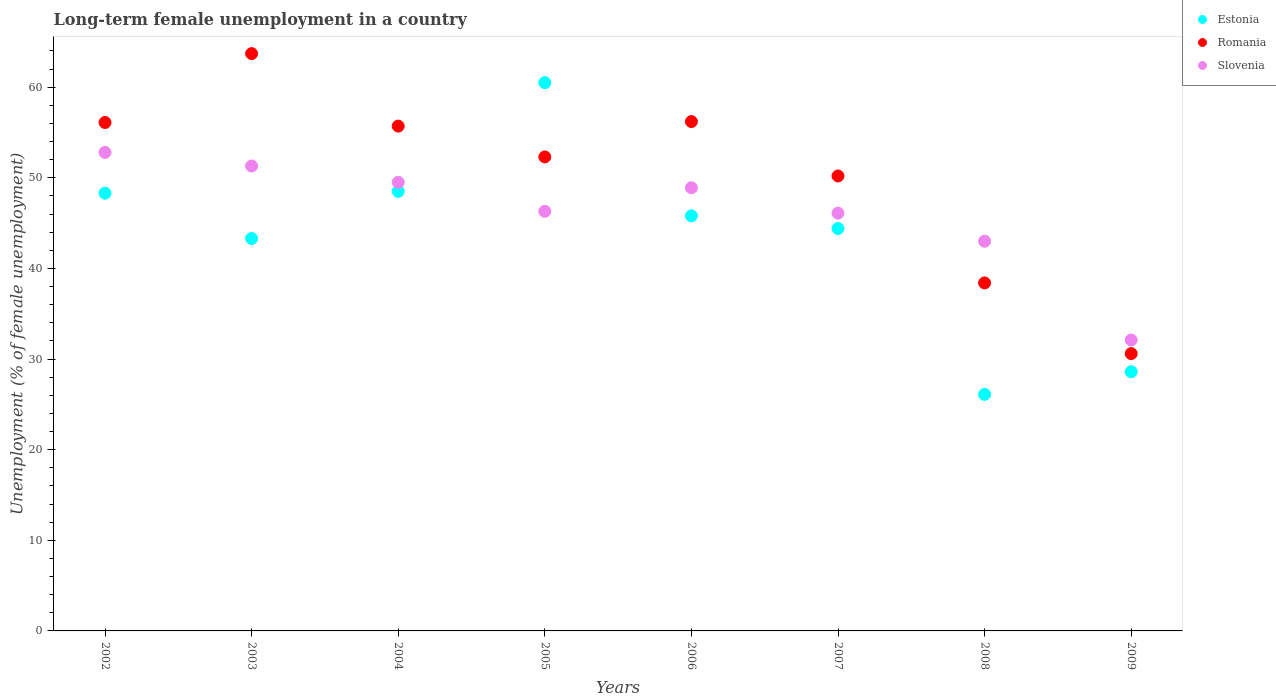How many different coloured dotlines are there?
Your answer should be compact. 3. Is the number of dotlines equal to the number of legend labels?
Offer a very short reply. Yes. What is the percentage of long-term unemployed female population in Estonia in 2002?
Offer a terse response. 48.3. Across all years, what is the maximum percentage of long-term unemployed female population in Slovenia?
Offer a very short reply. 52.8. Across all years, what is the minimum percentage of long-term unemployed female population in Romania?
Provide a succinct answer. 30.6. In which year was the percentage of long-term unemployed female population in Romania maximum?
Offer a very short reply. 2003. In which year was the percentage of long-term unemployed female population in Estonia minimum?
Make the answer very short. 2008. What is the total percentage of long-term unemployed female population in Estonia in the graph?
Offer a very short reply. 345.5. What is the difference between the percentage of long-term unemployed female population in Romania in 2002 and that in 2003?
Keep it short and to the point. -7.6. What is the difference between the percentage of long-term unemployed female population in Slovenia in 2005 and the percentage of long-term unemployed female population in Estonia in 2009?
Offer a very short reply. 17.7. What is the average percentage of long-term unemployed female population in Estonia per year?
Your answer should be compact. 43.19. In the year 2009, what is the difference between the percentage of long-term unemployed female population in Estonia and percentage of long-term unemployed female population in Romania?
Your response must be concise. -2. In how many years, is the percentage of long-term unemployed female population in Romania greater than 42 %?
Offer a very short reply. 6. What is the ratio of the percentage of long-term unemployed female population in Romania in 2005 to that in 2009?
Ensure brevity in your answer.  1.71. Is the difference between the percentage of long-term unemployed female population in Estonia in 2002 and 2008 greater than the difference between the percentage of long-term unemployed female population in Romania in 2002 and 2008?
Provide a short and direct response. Yes. What is the difference between the highest and the lowest percentage of long-term unemployed female population in Romania?
Your answer should be very brief. 33.1. Does the percentage of long-term unemployed female population in Slovenia monotonically increase over the years?
Your answer should be very brief. No. How many dotlines are there?
Your answer should be very brief. 3. What is the difference between two consecutive major ticks on the Y-axis?
Ensure brevity in your answer.  10. Does the graph contain any zero values?
Provide a short and direct response. No. How many legend labels are there?
Ensure brevity in your answer.  3. How are the legend labels stacked?
Your answer should be compact. Vertical. What is the title of the graph?
Give a very brief answer. Long-term female unemployment in a country. Does "Monaco" appear as one of the legend labels in the graph?
Provide a short and direct response. No. What is the label or title of the X-axis?
Give a very brief answer. Years. What is the label or title of the Y-axis?
Offer a terse response. Unemployment (% of female unemployment). What is the Unemployment (% of female unemployment) of Estonia in 2002?
Your answer should be very brief. 48.3. What is the Unemployment (% of female unemployment) of Romania in 2002?
Provide a short and direct response. 56.1. What is the Unemployment (% of female unemployment) of Slovenia in 2002?
Keep it short and to the point. 52.8. What is the Unemployment (% of female unemployment) of Estonia in 2003?
Your response must be concise. 43.3. What is the Unemployment (% of female unemployment) in Romania in 2003?
Ensure brevity in your answer.  63.7. What is the Unemployment (% of female unemployment) in Slovenia in 2003?
Offer a very short reply. 51.3. What is the Unemployment (% of female unemployment) of Estonia in 2004?
Keep it short and to the point. 48.5. What is the Unemployment (% of female unemployment) in Romania in 2004?
Your answer should be very brief. 55.7. What is the Unemployment (% of female unemployment) of Slovenia in 2004?
Keep it short and to the point. 49.5. What is the Unemployment (% of female unemployment) of Estonia in 2005?
Ensure brevity in your answer.  60.5. What is the Unemployment (% of female unemployment) of Romania in 2005?
Your answer should be compact. 52.3. What is the Unemployment (% of female unemployment) in Slovenia in 2005?
Offer a very short reply. 46.3. What is the Unemployment (% of female unemployment) of Estonia in 2006?
Offer a very short reply. 45.8. What is the Unemployment (% of female unemployment) of Romania in 2006?
Keep it short and to the point. 56.2. What is the Unemployment (% of female unemployment) in Slovenia in 2006?
Ensure brevity in your answer.  48.9. What is the Unemployment (% of female unemployment) of Estonia in 2007?
Make the answer very short. 44.4. What is the Unemployment (% of female unemployment) of Romania in 2007?
Give a very brief answer. 50.2. What is the Unemployment (% of female unemployment) in Slovenia in 2007?
Provide a succinct answer. 46.1. What is the Unemployment (% of female unemployment) in Estonia in 2008?
Give a very brief answer. 26.1. What is the Unemployment (% of female unemployment) of Romania in 2008?
Ensure brevity in your answer.  38.4. What is the Unemployment (% of female unemployment) of Slovenia in 2008?
Provide a succinct answer. 43. What is the Unemployment (% of female unemployment) in Estonia in 2009?
Your answer should be compact. 28.6. What is the Unemployment (% of female unemployment) in Romania in 2009?
Provide a succinct answer. 30.6. What is the Unemployment (% of female unemployment) of Slovenia in 2009?
Make the answer very short. 32.1. Across all years, what is the maximum Unemployment (% of female unemployment) in Estonia?
Your answer should be very brief. 60.5. Across all years, what is the maximum Unemployment (% of female unemployment) in Romania?
Offer a terse response. 63.7. Across all years, what is the maximum Unemployment (% of female unemployment) in Slovenia?
Ensure brevity in your answer.  52.8. Across all years, what is the minimum Unemployment (% of female unemployment) in Estonia?
Your response must be concise. 26.1. Across all years, what is the minimum Unemployment (% of female unemployment) of Romania?
Offer a very short reply. 30.6. Across all years, what is the minimum Unemployment (% of female unemployment) in Slovenia?
Provide a succinct answer. 32.1. What is the total Unemployment (% of female unemployment) of Estonia in the graph?
Provide a short and direct response. 345.5. What is the total Unemployment (% of female unemployment) of Romania in the graph?
Ensure brevity in your answer.  403.2. What is the total Unemployment (% of female unemployment) of Slovenia in the graph?
Keep it short and to the point. 370. What is the difference between the Unemployment (% of female unemployment) in Estonia in 2002 and that in 2004?
Your response must be concise. -0.2. What is the difference between the Unemployment (% of female unemployment) of Slovenia in 2002 and that in 2004?
Your answer should be compact. 3.3. What is the difference between the Unemployment (% of female unemployment) of Slovenia in 2002 and that in 2005?
Your response must be concise. 6.5. What is the difference between the Unemployment (% of female unemployment) in Estonia in 2002 and that in 2006?
Make the answer very short. 2.5. What is the difference between the Unemployment (% of female unemployment) of Romania in 2002 and that in 2006?
Ensure brevity in your answer.  -0.1. What is the difference between the Unemployment (% of female unemployment) in Slovenia in 2002 and that in 2006?
Offer a terse response. 3.9. What is the difference between the Unemployment (% of female unemployment) of Estonia in 2002 and that in 2007?
Ensure brevity in your answer.  3.9. What is the difference between the Unemployment (% of female unemployment) of Estonia in 2002 and that in 2008?
Provide a short and direct response. 22.2. What is the difference between the Unemployment (% of female unemployment) in Romania in 2002 and that in 2008?
Offer a very short reply. 17.7. What is the difference between the Unemployment (% of female unemployment) of Slovenia in 2002 and that in 2008?
Give a very brief answer. 9.8. What is the difference between the Unemployment (% of female unemployment) of Estonia in 2002 and that in 2009?
Provide a succinct answer. 19.7. What is the difference between the Unemployment (% of female unemployment) of Romania in 2002 and that in 2009?
Offer a very short reply. 25.5. What is the difference between the Unemployment (% of female unemployment) of Slovenia in 2002 and that in 2009?
Your response must be concise. 20.7. What is the difference between the Unemployment (% of female unemployment) of Slovenia in 2003 and that in 2004?
Provide a succinct answer. 1.8. What is the difference between the Unemployment (% of female unemployment) in Estonia in 2003 and that in 2005?
Your response must be concise. -17.2. What is the difference between the Unemployment (% of female unemployment) of Romania in 2003 and that in 2005?
Make the answer very short. 11.4. What is the difference between the Unemployment (% of female unemployment) of Slovenia in 2003 and that in 2005?
Make the answer very short. 5. What is the difference between the Unemployment (% of female unemployment) in Romania in 2003 and that in 2006?
Your response must be concise. 7.5. What is the difference between the Unemployment (% of female unemployment) in Slovenia in 2003 and that in 2006?
Your answer should be very brief. 2.4. What is the difference between the Unemployment (% of female unemployment) of Slovenia in 2003 and that in 2007?
Your answer should be very brief. 5.2. What is the difference between the Unemployment (% of female unemployment) in Estonia in 2003 and that in 2008?
Ensure brevity in your answer.  17.2. What is the difference between the Unemployment (% of female unemployment) of Romania in 2003 and that in 2008?
Keep it short and to the point. 25.3. What is the difference between the Unemployment (% of female unemployment) of Romania in 2003 and that in 2009?
Your answer should be compact. 33.1. What is the difference between the Unemployment (% of female unemployment) of Estonia in 2004 and that in 2006?
Provide a succinct answer. 2.7. What is the difference between the Unemployment (% of female unemployment) in Romania in 2004 and that in 2007?
Your answer should be compact. 5.5. What is the difference between the Unemployment (% of female unemployment) of Slovenia in 2004 and that in 2007?
Your response must be concise. 3.4. What is the difference between the Unemployment (% of female unemployment) of Estonia in 2004 and that in 2008?
Provide a succinct answer. 22.4. What is the difference between the Unemployment (% of female unemployment) of Romania in 2004 and that in 2008?
Ensure brevity in your answer.  17.3. What is the difference between the Unemployment (% of female unemployment) of Estonia in 2004 and that in 2009?
Provide a succinct answer. 19.9. What is the difference between the Unemployment (% of female unemployment) in Romania in 2004 and that in 2009?
Your response must be concise. 25.1. What is the difference between the Unemployment (% of female unemployment) in Estonia in 2005 and that in 2006?
Give a very brief answer. 14.7. What is the difference between the Unemployment (% of female unemployment) of Romania in 2005 and that in 2006?
Your answer should be very brief. -3.9. What is the difference between the Unemployment (% of female unemployment) of Estonia in 2005 and that in 2007?
Make the answer very short. 16.1. What is the difference between the Unemployment (% of female unemployment) in Estonia in 2005 and that in 2008?
Provide a short and direct response. 34.4. What is the difference between the Unemployment (% of female unemployment) of Estonia in 2005 and that in 2009?
Provide a succinct answer. 31.9. What is the difference between the Unemployment (% of female unemployment) in Romania in 2005 and that in 2009?
Your response must be concise. 21.7. What is the difference between the Unemployment (% of female unemployment) in Romania in 2006 and that in 2007?
Provide a succinct answer. 6. What is the difference between the Unemployment (% of female unemployment) of Slovenia in 2006 and that in 2007?
Offer a very short reply. 2.8. What is the difference between the Unemployment (% of female unemployment) in Estonia in 2006 and that in 2008?
Keep it short and to the point. 19.7. What is the difference between the Unemployment (% of female unemployment) in Romania in 2006 and that in 2008?
Provide a short and direct response. 17.8. What is the difference between the Unemployment (% of female unemployment) of Romania in 2006 and that in 2009?
Ensure brevity in your answer.  25.6. What is the difference between the Unemployment (% of female unemployment) of Slovenia in 2006 and that in 2009?
Give a very brief answer. 16.8. What is the difference between the Unemployment (% of female unemployment) in Estonia in 2007 and that in 2008?
Your answer should be compact. 18.3. What is the difference between the Unemployment (% of female unemployment) of Romania in 2007 and that in 2009?
Keep it short and to the point. 19.6. What is the difference between the Unemployment (% of female unemployment) in Slovenia in 2007 and that in 2009?
Provide a short and direct response. 14. What is the difference between the Unemployment (% of female unemployment) of Estonia in 2008 and that in 2009?
Keep it short and to the point. -2.5. What is the difference between the Unemployment (% of female unemployment) of Romania in 2008 and that in 2009?
Provide a short and direct response. 7.8. What is the difference between the Unemployment (% of female unemployment) in Estonia in 2002 and the Unemployment (% of female unemployment) in Romania in 2003?
Keep it short and to the point. -15.4. What is the difference between the Unemployment (% of female unemployment) of Romania in 2002 and the Unemployment (% of female unemployment) of Slovenia in 2003?
Provide a short and direct response. 4.8. What is the difference between the Unemployment (% of female unemployment) in Estonia in 2002 and the Unemployment (% of female unemployment) in Romania in 2004?
Provide a succinct answer. -7.4. What is the difference between the Unemployment (% of female unemployment) of Romania in 2002 and the Unemployment (% of female unemployment) of Slovenia in 2004?
Your answer should be very brief. 6.6. What is the difference between the Unemployment (% of female unemployment) in Romania in 2002 and the Unemployment (% of female unemployment) in Slovenia in 2005?
Offer a terse response. 9.8. What is the difference between the Unemployment (% of female unemployment) of Estonia in 2002 and the Unemployment (% of female unemployment) of Romania in 2007?
Offer a very short reply. -1.9. What is the difference between the Unemployment (% of female unemployment) in Estonia in 2002 and the Unemployment (% of female unemployment) in Romania in 2008?
Your response must be concise. 9.9. What is the difference between the Unemployment (% of female unemployment) of Estonia in 2002 and the Unemployment (% of female unemployment) of Slovenia in 2008?
Ensure brevity in your answer.  5.3. What is the difference between the Unemployment (% of female unemployment) in Estonia in 2002 and the Unemployment (% of female unemployment) in Romania in 2009?
Ensure brevity in your answer.  17.7. What is the difference between the Unemployment (% of female unemployment) of Estonia in 2002 and the Unemployment (% of female unemployment) of Slovenia in 2009?
Your response must be concise. 16.2. What is the difference between the Unemployment (% of female unemployment) in Estonia in 2003 and the Unemployment (% of female unemployment) in Romania in 2005?
Provide a succinct answer. -9. What is the difference between the Unemployment (% of female unemployment) of Estonia in 2003 and the Unemployment (% of female unemployment) of Slovenia in 2005?
Offer a very short reply. -3. What is the difference between the Unemployment (% of female unemployment) of Romania in 2003 and the Unemployment (% of female unemployment) of Slovenia in 2006?
Offer a terse response. 14.8. What is the difference between the Unemployment (% of female unemployment) of Estonia in 2003 and the Unemployment (% of female unemployment) of Romania in 2007?
Provide a short and direct response. -6.9. What is the difference between the Unemployment (% of female unemployment) in Estonia in 2003 and the Unemployment (% of female unemployment) in Slovenia in 2007?
Ensure brevity in your answer.  -2.8. What is the difference between the Unemployment (% of female unemployment) of Estonia in 2003 and the Unemployment (% of female unemployment) of Romania in 2008?
Make the answer very short. 4.9. What is the difference between the Unemployment (% of female unemployment) in Romania in 2003 and the Unemployment (% of female unemployment) in Slovenia in 2008?
Give a very brief answer. 20.7. What is the difference between the Unemployment (% of female unemployment) of Estonia in 2003 and the Unemployment (% of female unemployment) of Slovenia in 2009?
Offer a very short reply. 11.2. What is the difference between the Unemployment (% of female unemployment) of Romania in 2003 and the Unemployment (% of female unemployment) of Slovenia in 2009?
Provide a short and direct response. 31.6. What is the difference between the Unemployment (% of female unemployment) of Estonia in 2004 and the Unemployment (% of female unemployment) of Romania in 2005?
Offer a very short reply. -3.8. What is the difference between the Unemployment (% of female unemployment) of Romania in 2004 and the Unemployment (% of female unemployment) of Slovenia in 2005?
Provide a succinct answer. 9.4. What is the difference between the Unemployment (% of female unemployment) of Estonia in 2004 and the Unemployment (% of female unemployment) of Romania in 2006?
Give a very brief answer. -7.7. What is the difference between the Unemployment (% of female unemployment) in Estonia in 2004 and the Unemployment (% of female unemployment) in Slovenia in 2006?
Your answer should be very brief. -0.4. What is the difference between the Unemployment (% of female unemployment) in Romania in 2004 and the Unemployment (% of female unemployment) in Slovenia in 2006?
Give a very brief answer. 6.8. What is the difference between the Unemployment (% of female unemployment) of Estonia in 2004 and the Unemployment (% of female unemployment) of Romania in 2009?
Provide a short and direct response. 17.9. What is the difference between the Unemployment (% of female unemployment) in Estonia in 2004 and the Unemployment (% of female unemployment) in Slovenia in 2009?
Your response must be concise. 16.4. What is the difference between the Unemployment (% of female unemployment) of Romania in 2004 and the Unemployment (% of female unemployment) of Slovenia in 2009?
Keep it short and to the point. 23.6. What is the difference between the Unemployment (% of female unemployment) in Estonia in 2005 and the Unemployment (% of female unemployment) in Romania in 2006?
Provide a succinct answer. 4.3. What is the difference between the Unemployment (% of female unemployment) in Estonia in 2005 and the Unemployment (% of female unemployment) in Slovenia in 2006?
Provide a short and direct response. 11.6. What is the difference between the Unemployment (% of female unemployment) of Romania in 2005 and the Unemployment (% of female unemployment) of Slovenia in 2007?
Your answer should be compact. 6.2. What is the difference between the Unemployment (% of female unemployment) in Estonia in 2005 and the Unemployment (% of female unemployment) in Romania in 2008?
Provide a succinct answer. 22.1. What is the difference between the Unemployment (% of female unemployment) in Estonia in 2005 and the Unemployment (% of female unemployment) in Romania in 2009?
Ensure brevity in your answer.  29.9. What is the difference between the Unemployment (% of female unemployment) of Estonia in 2005 and the Unemployment (% of female unemployment) of Slovenia in 2009?
Give a very brief answer. 28.4. What is the difference between the Unemployment (% of female unemployment) in Romania in 2005 and the Unemployment (% of female unemployment) in Slovenia in 2009?
Your answer should be compact. 20.2. What is the difference between the Unemployment (% of female unemployment) in Romania in 2006 and the Unemployment (% of female unemployment) in Slovenia in 2007?
Ensure brevity in your answer.  10.1. What is the difference between the Unemployment (% of female unemployment) of Estonia in 2006 and the Unemployment (% of female unemployment) of Romania in 2008?
Give a very brief answer. 7.4. What is the difference between the Unemployment (% of female unemployment) of Romania in 2006 and the Unemployment (% of female unemployment) of Slovenia in 2008?
Offer a very short reply. 13.2. What is the difference between the Unemployment (% of female unemployment) in Estonia in 2006 and the Unemployment (% of female unemployment) in Romania in 2009?
Offer a very short reply. 15.2. What is the difference between the Unemployment (% of female unemployment) in Romania in 2006 and the Unemployment (% of female unemployment) in Slovenia in 2009?
Offer a very short reply. 24.1. What is the difference between the Unemployment (% of female unemployment) of Estonia in 2007 and the Unemployment (% of female unemployment) of Slovenia in 2008?
Offer a terse response. 1.4. What is the difference between the Unemployment (% of female unemployment) of Romania in 2007 and the Unemployment (% of female unemployment) of Slovenia in 2008?
Provide a succinct answer. 7.2. What is the difference between the Unemployment (% of female unemployment) of Estonia in 2007 and the Unemployment (% of female unemployment) of Slovenia in 2009?
Ensure brevity in your answer.  12.3. What is the difference between the Unemployment (% of female unemployment) of Romania in 2007 and the Unemployment (% of female unemployment) of Slovenia in 2009?
Offer a terse response. 18.1. What is the difference between the Unemployment (% of female unemployment) in Estonia in 2008 and the Unemployment (% of female unemployment) in Romania in 2009?
Offer a very short reply. -4.5. What is the average Unemployment (% of female unemployment) in Estonia per year?
Give a very brief answer. 43.19. What is the average Unemployment (% of female unemployment) of Romania per year?
Your answer should be compact. 50.4. What is the average Unemployment (% of female unemployment) in Slovenia per year?
Offer a terse response. 46.25. In the year 2002, what is the difference between the Unemployment (% of female unemployment) in Estonia and Unemployment (% of female unemployment) in Romania?
Your answer should be compact. -7.8. In the year 2002, what is the difference between the Unemployment (% of female unemployment) in Romania and Unemployment (% of female unemployment) in Slovenia?
Provide a short and direct response. 3.3. In the year 2003, what is the difference between the Unemployment (% of female unemployment) of Estonia and Unemployment (% of female unemployment) of Romania?
Keep it short and to the point. -20.4. In the year 2004, what is the difference between the Unemployment (% of female unemployment) in Estonia and Unemployment (% of female unemployment) in Romania?
Your answer should be very brief. -7.2. In the year 2004, what is the difference between the Unemployment (% of female unemployment) of Romania and Unemployment (% of female unemployment) of Slovenia?
Keep it short and to the point. 6.2. In the year 2005, what is the difference between the Unemployment (% of female unemployment) of Romania and Unemployment (% of female unemployment) of Slovenia?
Provide a succinct answer. 6. In the year 2006, what is the difference between the Unemployment (% of female unemployment) of Estonia and Unemployment (% of female unemployment) of Slovenia?
Your answer should be very brief. -3.1. In the year 2006, what is the difference between the Unemployment (% of female unemployment) of Romania and Unemployment (% of female unemployment) of Slovenia?
Offer a terse response. 7.3. In the year 2007, what is the difference between the Unemployment (% of female unemployment) in Estonia and Unemployment (% of female unemployment) in Romania?
Make the answer very short. -5.8. In the year 2007, what is the difference between the Unemployment (% of female unemployment) in Estonia and Unemployment (% of female unemployment) in Slovenia?
Your answer should be compact. -1.7. In the year 2007, what is the difference between the Unemployment (% of female unemployment) in Romania and Unemployment (% of female unemployment) in Slovenia?
Your answer should be compact. 4.1. In the year 2008, what is the difference between the Unemployment (% of female unemployment) of Estonia and Unemployment (% of female unemployment) of Romania?
Your answer should be compact. -12.3. In the year 2008, what is the difference between the Unemployment (% of female unemployment) in Estonia and Unemployment (% of female unemployment) in Slovenia?
Your response must be concise. -16.9. In the year 2008, what is the difference between the Unemployment (% of female unemployment) in Romania and Unemployment (% of female unemployment) in Slovenia?
Provide a short and direct response. -4.6. In the year 2009, what is the difference between the Unemployment (% of female unemployment) of Estonia and Unemployment (% of female unemployment) of Slovenia?
Keep it short and to the point. -3.5. What is the ratio of the Unemployment (% of female unemployment) of Estonia in 2002 to that in 2003?
Make the answer very short. 1.12. What is the ratio of the Unemployment (% of female unemployment) of Romania in 2002 to that in 2003?
Your answer should be very brief. 0.88. What is the ratio of the Unemployment (% of female unemployment) of Slovenia in 2002 to that in 2003?
Make the answer very short. 1.03. What is the ratio of the Unemployment (% of female unemployment) of Romania in 2002 to that in 2004?
Keep it short and to the point. 1.01. What is the ratio of the Unemployment (% of female unemployment) in Slovenia in 2002 to that in 2004?
Make the answer very short. 1.07. What is the ratio of the Unemployment (% of female unemployment) in Estonia in 2002 to that in 2005?
Your answer should be compact. 0.8. What is the ratio of the Unemployment (% of female unemployment) in Romania in 2002 to that in 2005?
Your answer should be compact. 1.07. What is the ratio of the Unemployment (% of female unemployment) of Slovenia in 2002 to that in 2005?
Your answer should be compact. 1.14. What is the ratio of the Unemployment (% of female unemployment) in Estonia in 2002 to that in 2006?
Offer a terse response. 1.05. What is the ratio of the Unemployment (% of female unemployment) in Romania in 2002 to that in 2006?
Provide a succinct answer. 1. What is the ratio of the Unemployment (% of female unemployment) of Slovenia in 2002 to that in 2006?
Make the answer very short. 1.08. What is the ratio of the Unemployment (% of female unemployment) in Estonia in 2002 to that in 2007?
Keep it short and to the point. 1.09. What is the ratio of the Unemployment (% of female unemployment) in Romania in 2002 to that in 2007?
Make the answer very short. 1.12. What is the ratio of the Unemployment (% of female unemployment) in Slovenia in 2002 to that in 2007?
Your response must be concise. 1.15. What is the ratio of the Unemployment (% of female unemployment) of Estonia in 2002 to that in 2008?
Your answer should be compact. 1.85. What is the ratio of the Unemployment (% of female unemployment) of Romania in 2002 to that in 2008?
Make the answer very short. 1.46. What is the ratio of the Unemployment (% of female unemployment) of Slovenia in 2002 to that in 2008?
Offer a terse response. 1.23. What is the ratio of the Unemployment (% of female unemployment) in Estonia in 2002 to that in 2009?
Make the answer very short. 1.69. What is the ratio of the Unemployment (% of female unemployment) of Romania in 2002 to that in 2009?
Your response must be concise. 1.83. What is the ratio of the Unemployment (% of female unemployment) of Slovenia in 2002 to that in 2009?
Offer a terse response. 1.64. What is the ratio of the Unemployment (% of female unemployment) of Estonia in 2003 to that in 2004?
Offer a very short reply. 0.89. What is the ratio of the Unemployment (% of female unemployment) in Romania in 2003 to that in 2004?
Make the answer very short. 1.14. What is the ratio of the Unemployment (% of female unemployment) in Slovenia in 2003 to that in 2004?
Provide a short and direct response. 1.04. What is the ratio of the Unemployment (% of female unemployment) of Estonia in 2003 to that in 2005?
Provide a short and direct response. 0.72. What is the ratio of the Unemployment (% of female unemployment) in Romania in 2003 to that in 2005?
Give a very brief answer. 1.22. What is the ratio of the Unemployment (% of female unemployment) in Slovenia in 2003 to that in 2005?
Your answer should be compact. 1.11. What is the ratio of the Unemployment (% of female unemployment) of Estonia in 2003 to that in 2006?
Keep it short and to the point. 0.95. What is the ratio of the Unemployment (% of female unemployment) of Romania in 2003 to that in 2006?
Ensure brevity in your answer.  1.13. What is the ratio of the Unemployment (% of female unemployment) of Slovenia in 2003 to that in 2006?
Your answer should be compact. 1.05. What is the ratio of the Unemployment (% of female unemployment) of Estonia in 2003 to that in 2007?
Ensure brevity in your answer.  0.98. What is the ratio of the Unemployment (% of female unemployment) in Romania in 2003 to that in 2007?
Your response must be concise. 1.27. What is the ratio of the Unemployment (% of female unemployment) in Slovenia in 2003 to that in 2007?
Keep it short and to the point. 1.11. What is the ratio of the Unemployment (% of female unemployment) of Estonia in 2003 to that in 2008?
Your answer should be very brief. 1.66. What is the ratio of the Unemployment (% of female unemployment) in Romania in 2003 to that in 2008?
Your response must be concise. 1.66. What is the ratio of the Unemployment (% of female unemployment) of Slovenia in 2003 to that in 2008?
Your answer should be very brief. 1.19. What is the ratio of the Unemployment (% of female unemployment) in Estonia in 2003 to that in 2009?
Provide a short and direct response. 1.51. What is the ratio of the Unemployment (% of female unemployment) in Romania in 2003 to that in 2009?
Your answer should be very brief. 2.08. What is the ratio of the Unemployment (% of female unemployment) in Slovenia in 2003 to that in 2009?
Provide a short and direct response. 1.6. What is the ratio of the Unemployment (% of female unemployment) of Estonia in 2004 to that in 2005?
Offer a terse response. 0.8. What is the ratio of the Unemployment (% of female unemployment) in Romania in 2004 to that in 2005?
Your answer should be compact. 1.06. What is the ratio of the Unemployment (% of female unemployment) in Slovenia in 2004 to that in 2005?
Your response must be concise. 1.07. What is the ratio of the Unemployment (% of female unemployment) of Estonia in 2004 to that in 2006?
Offer a terse response. 1.06. What is the ratio of the Unemployment (% of female unemployment) of Romania in 2004 to that in 2006?
Ensure brevity in your answer.  0.99. What is the ratio of the Unemployment (% of female unemployment) in Slovenia in 2004 to that in 2006?
Your answer should be compact. 1.01. What is the ratio of the Unemployment (% of female unemployment) in Estonia in 2004 to that in 2007?
Keep it short and to the point. 1.09. What is the ratio of the Unemployment (% of female unemployment) in Romania in 2004 to that in 2007?
Give a very brief answer. 1.11. What is the ratio of the Unemployment (% of female unemployment) in Slovenia in 2004 to that in 2007?
Provide a short and direct response. 1.07. What is the ratio of the Unemployment (% of female unemployment) in Estonia in 2004 to that in 2008?
Give a very brief answer. 1.86. What is the ratio of the Unemployment (% of female unemployment) in Romania in 2004 to that in 2008?
Your answer should be compact. 1.45. What is the ratio of the Unemployment (% of female unemployment) in Slovenia in 2004 to that in 2008?
Keep it short and to the point. 1.15. What is the ratio of the Unemployment (% of female unemployment) of Estonia in 2004 to that in 2009?
Make the answer very short. 1.7. What is the ratio of the Unemployment (% of female unemployment) of Romania in 2004 to that in 2009?
Give a very brief answer. 1.82. What is the ratio of the Unemployment (% of female unemployment) in Slovenia in 2004 to that in 2009?
Your answer should be very brief. 1.54. What is the ratio of the Unemployment (% of female unemployment) of Estonia in 2005 to that in 2006?
Your answer should be very brief. 1.32. What is the ratio of the Unemployment (% of female unemployment) of Romania in 2005 to that in 2006?
Make the answer very short. 0.93. What is the ratio of the Unemployment (% of female unemployment) in Slovenia in 2005 to that in 2006?
Keep it short and to the point. 0.95. What is the ratio of the Unemployment (% of female unemployment) in Estonia in 2005 to that in 2007?
Provide a short and direct response. 1.36. What is the ratio of the Unemployment (% of female unemployment) of Romania in 2005 to that in 2007?
Offer a terse response. 1.04. What is the ratio of the Unemployment (% of female unemployment) of Estonia in 2005 to that in 2008?
Your answer should be compact. 2.32. What is the ratio of the Unemployment (% of female unemployment) of Romania in 2005 to that in 2008?
Provide a short and direct response. 1.36. What is the ratio of the Unemployment (% of female unemployment) in Slovenia in 2005 to that in 2008?
Offer a terse response. 1.08. What is the ratio of the Unemployment (% of female unemployment) in Estonia in 2005 to that in 2009?
Your answer should be compact. 2.12. What is the ratio of the Unemployment (% of female unemployment) in Romania in 2005 to that in 2009?
Offer a very short reply. 1.71. What is the ratio of the Unemployment (% of female unemployment) of Slovenia in 2005 to that in 2009?
Offer a terse response. 1.44. What is the ratio of the Unemployment (% of female unemployment) of Estonia in 2006 to that in 2007?
Make the answer very short. 1.03. What is the ratio of the Unemployment (% of female unemployment) of Romania in 2006 to that in 2007?
Your response must be concise. 1.12. What is the ratio of the Unemployment (% of female unemployment) of Slovenia in 2006 to that in 2007?
Your response must be concise. 1.06. What is the ratio of the Unemployment (% of female unemployment) in Estonia in 2006 to that in 2008?
Your answer should be compact. 1.75. What is the ratio of the Unemployment (% of female unemployment) in Romania in 2006 to that in 2008?
Give a very brief answer. 1.46. What is the ratio of the Unemployment (% of female unemployment) in Slovenia in 2006 to that in 2008?
Give a very brief answer. 1.14. What is the ratio of the Unemployment (% of female unemployment) of Estonia in 2006 to that in 2009?
Provide a short and direct response. 1.6. What is the ratio of the Unemployment (% of female unemployment) in Romania in 2006 to that in 2009?
Ensure brevity in your answer.  1.84. What is the ratio of the Unemployment (% of female unemployment) in Slovenia in 2006 to that in 2009?
Make the answer very short. 1.52. What is the ratio of the Unemployment (% of female unemployment) in Estonia in 2007 to that in 2008?
Offer a very short reply. 1.7. What is the ratio of the Unemployment (% of female unemployment) of Romania in 2007 to that in 2008?
Offer a terse response. 1.31. What is the ratio of the Unemployment (% of female unemployment) in Slovenia in 2007 to that in 2008?
Your response must be concise. 1.07. What is the ratio of the Unemployment (% of female unemployment) of Estonia in 2007 to that in 2009?
Your answer should be compact. 1.55. What is the ratio of the Unemployment (% of female unemployment) of Romania in 2007 to that in 2009?
Your answer should be very brief. 1.64. What is the ratio of the Unemployment (% of female unemployment) of Slovenia in 2007 to that in 2009?
Your answer should be very brief. 1.44. What is the ratio of the Unemployment (% of female unemployment) in Estonia in 2008 to that in 2009?
Offer a very short reply. 0.91. What is the ratio of the Unemployment (% of female unemployment) of Romania in 2008 to that in 2009?
Give a very brief answer. 1.25. What is the ratio of the Unemployment (% of female unemployment) in Slovenia in 2008 to that in 2009?
Provide a succinct answer. 1.34. What is the difference between the highest and the second highest Unemployment (% of female unemployment) of Estonia?
Provide a succinct answer. 12. What is the difference between the highest and the second highest Unemployment (% of female unemployment) of Romania?
Offer a very short reply. 7.5. What is the difference between the highest and the second highest Unemployment (% of female unemployment) of Slovenia?
Provide a short and direct response. 1.5. What is the difference between the highest and the lowest Unemployment (% of female unemployment) of Estonia?
Offer a terse response. 34.4. What is the difference between the highest and the lowest Unemployment (% of female unemployment) of Romania?
Keep it short and to the point. 33.1. What is the difference between the highest and the lowest Unemployment (% of female unemployment) in Slovenia?
Provide a succinct answer. 20.7. 